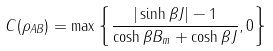Convert formula to latex. <formula><loc_0><loc_0><loc_500><loc_500>C ( \rho _ { A B } ) = \max \left \{ \frac { | \sinh \beta J | - 1 } { \cosh \beta B _ { m } + \cosh \beta J } , 0 \right \}</formula> 